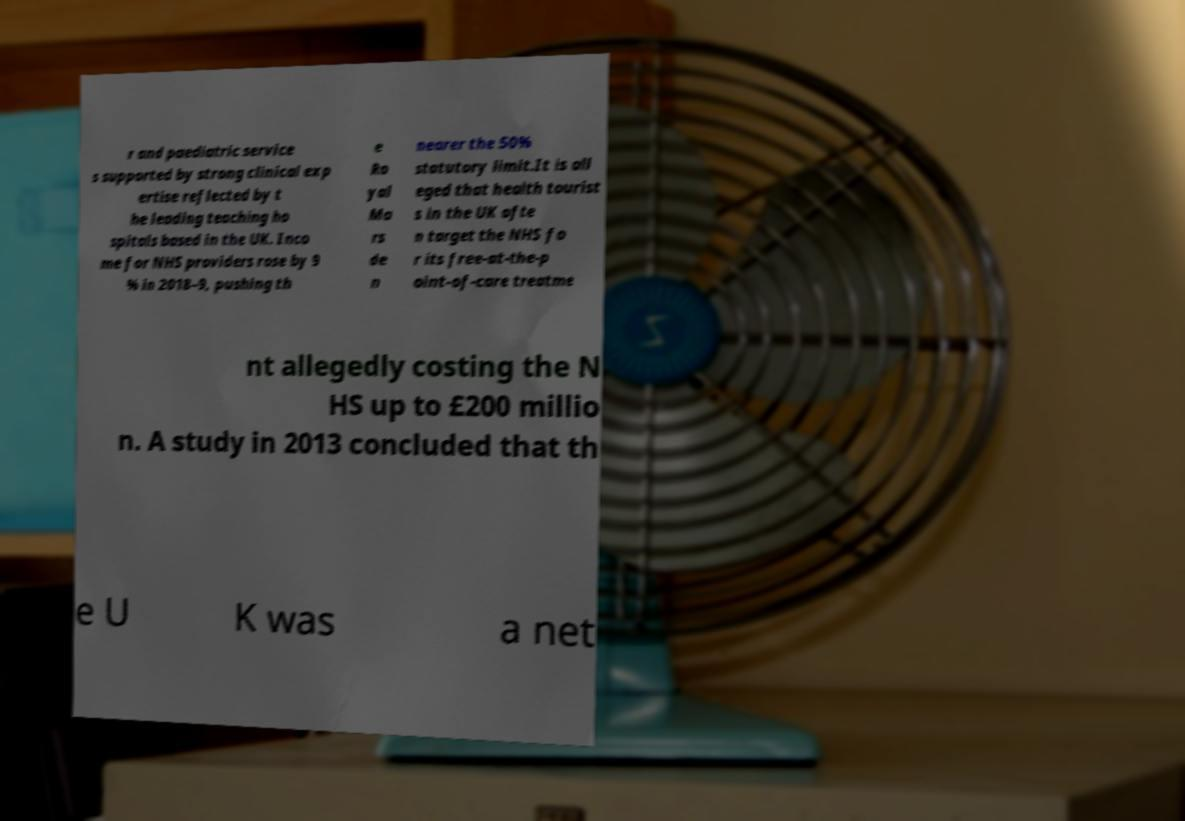Could you assist in decoding the text presented in this image and type it out clearly? r and paediatric service s supported by strong clinical exp ertise reflected by t he leading teaching ho spitals based in the UK. Inco me for NHS providers rose by 9 % in 2018–9, pushing th e Ro yal Ma rs de n nearer the 50% statutory limit.It is all eged that health tourist s in the UK ofte n target the NHS fo r its free-at-the-p oint-of-care treatme nt allegedly costing the N HS up to £200 millio n. A study in 2013 concluded that th e U K was a net 